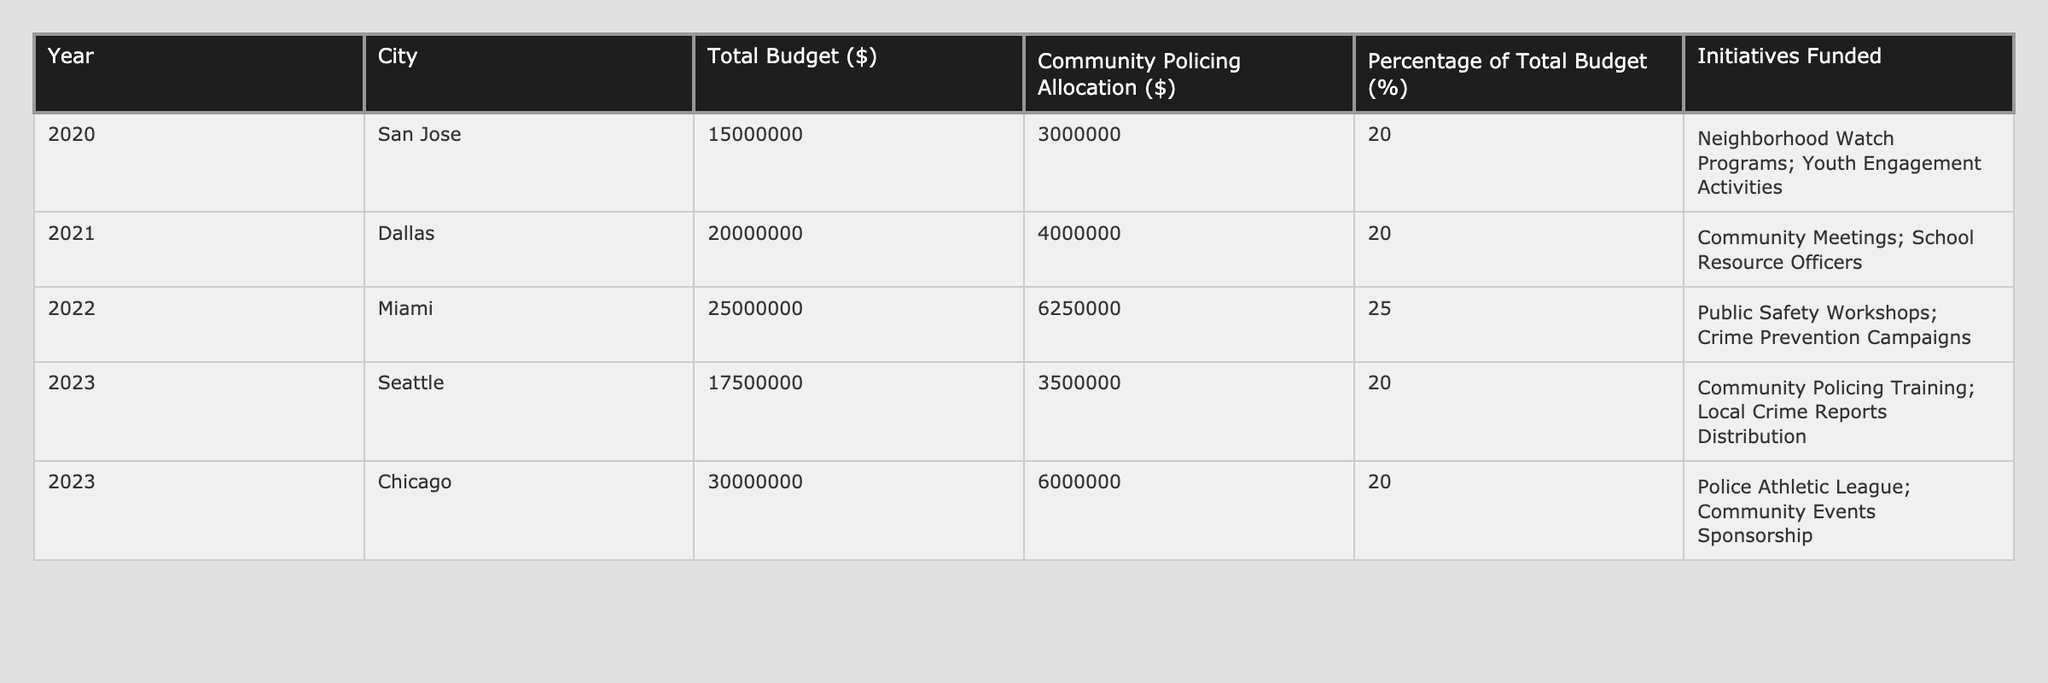What was the total budget allocated for community policing initiatives in 2022? The total budget for community policing initiatives in 2022 is listed under the "Total Budget" column for the city of Miami, which shows $25,000,000.
Answer: 25000000 In which year did the city of Miami allocate the highest percentage of its total budget to community policing? The table shows that in 2022, Miami allocated 25% of its total budget to community policing, which is the highest percentage compared to all other years.
Answer: 2022 What is the total amount allocated for community policing initiatives across all cities for the year 2023? Summing the community policing allocations for Seattle ($3,500,000) and Chicago ($6,000,000), we find that the total amount is $3,500,000 + $6,000,000 = $9,500,000.
Answer: 9500000 Did San Jose fund more initiatives in community policing than Dallas? According to the table, San Jose funded two initiatives (Neighborhood Watch Programs and Youth Engagement Activities) while Dallas funded two initiatives (Community Meetings and School Resource Officers), so it is false that San Jose funded more.
Answer: No What was the average community policing allocation for the years available in the table? To find the average, we sum the community policing allocations for all years: $3,000,000 + $4,000,000 + $6,250,000 + $3,500,000 + $6,000,000 = $22,750,000. Then, we divide by the number of years, which is 5, so $22,750,000 / 5 = $4,550,000.
Answer: 4550000 Which city had the highest total budget for community policing in the year 2021? Reviewing the table shows that the city with the highest total budget for community policing in the year 2021 is Dallas with a $20,000,000 budget.
Answer: Dallas Is the percentage of the total budget allocated to community policing in Seattle higher than that in San Jose? By looking at the percentages, Seattle allocated 20% of its total budget, while San Jose also allocated 20%, hence it is false that Seattle's percentage is higher.
Answer: No What was the difference in community policing allocation between Miami and San Jose in 2022? The community policing allocation for Miami is $6,250,000 and for San Jose is $3,000,000. The difference is $6,250,000 - $3,000,000 = $3,250,000.
Answer: 3250000 